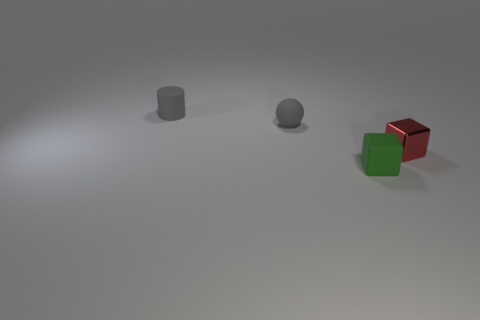Is there anything else that is made of the same material as the tiny red cube?
Offer a very short reply. No. Are there an equal number of tiny gray spheres on the right side of the green cube and big green cylinders?
Your answer should be very brief. Yes. Are there any other things that are the same color as the matte cube?
Make the answer very short. No. What shape is the small object that is both to the left of the small green thing and in front of the tiny gray matte cylinder?
Keep it short and to the point. Sphere. Are there an equal number of matte blocks behind the matte cylinder and red blocks to the left of the red object?
Your answer should be compact. Yes. What number of cylinders are either small green matte things or large cyan shiny things?
Offer a terse response. 0. What number of other gray spheres have the same material as the ball?
Your answer should be very brief. 0. What shape is the rubber object that is the same color as the cylinder?
Your response must be concise. Sphere. There is a object that is both right of the matte cylinder and to the left of the green rubber object; what is it made of?
Your response must be concise. Rubber. What shape is the rubber thing that is in front of the tiny red thing?
Provide a short and direct response. Cube. 